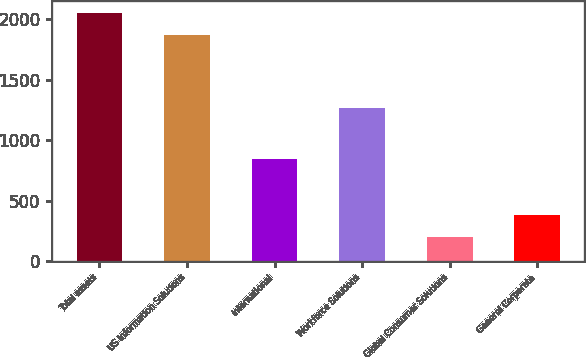Convert chart to OTSL. <chart><loc_0><loc_0><loc_500><loc_500><bar_chart><fcel>Total assets<fcel>US Information Solutions<fcel>International<fcel>Workforce Solutions<fcel>Global Consumer Solutions<fcel>General Corporate<nl><fcel>2051.31<fcel>1869.6<fcel>844.5<fcel>1268.5<fcel>197.9<fcel>379.61<nl></chart> 